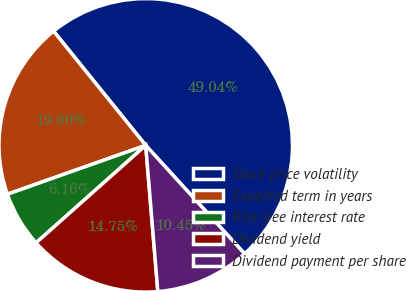Convert chart. <chart><loc_0><loc_0><loc_500><loc_500><pie_chart><fcel>Stock price volatility<fcel>Expected term in years<fcel>Risk-free interest rate<fcel>Dividend yield<fcel>Dividend payment per share<nl><fcel>49.04%<fcel>19.6%<fcel>6.16%<fcel>14.75%<fcel>10.45%<nl></chart> 